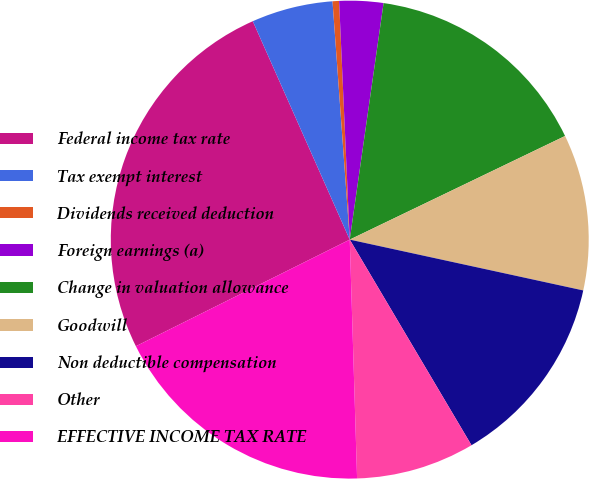Convert chart. <chart><loc_0><loc_0><loc_500><loc_500><pie_chart><fcel>Federal income tax rate<fcel>Tax exempt interest<fcel>Dividends received deduction<fcel>Foreign earnings (a)<fcel>Change in valuation allowance<fcel>Goodwill<fcel>Non deductible compensation<fcel>Other<fcel>EFFECTIVE INCOME TAX RATE<nl><fcel>25.71%<fcel>5.5%<fcel>0.44%<fcel>2.97%<fcel>15.6%<fcel>10.55%<fcel>13.08%<fcel>8.02%<fcel>18.13%<nl></chart> 